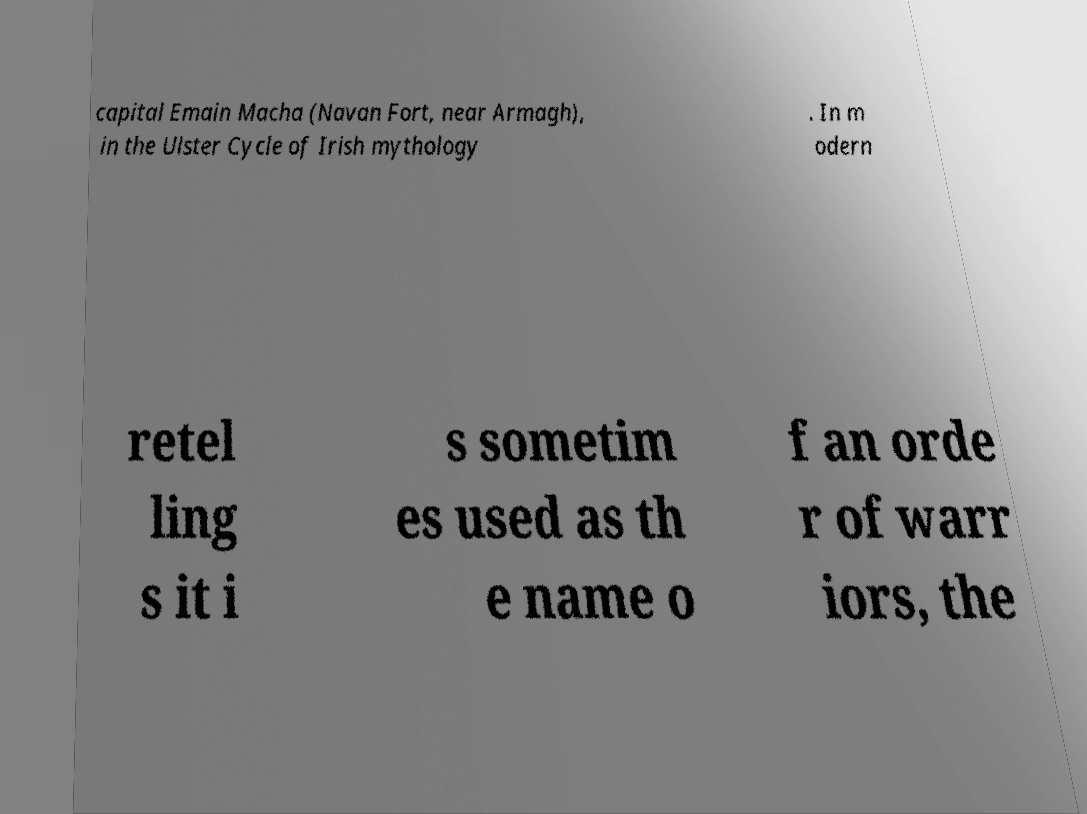Please read and relay the text visible in this image. What does it say? capital Emain Macha (Navan Fort, near Armagh), in the Ulster Cycle of Irish mythology . In m odern retel ling s it i s sometim es used as th e name o f an orde r of warr iors, the 